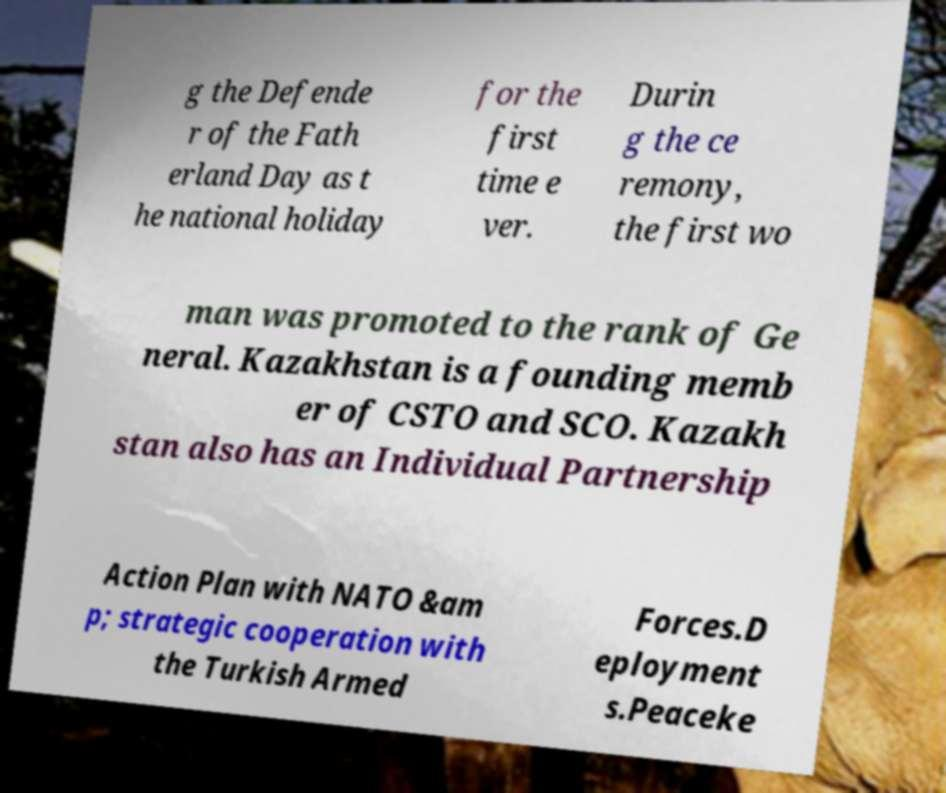Please read and relay the text visible in this image. What does it say? g the Defende r of the Fath erland Day as t he national holiday for the first time e ver. Durin g the ce remony, the first wo man was promoted to the rank of Ge neral. Kazakhstan is a founding memb er of CSTO and SCO. Kazakh stan also has an Individual Partnership Action Plan with NATO &am p; strategic cooperation with the Turkish Armed Forces.D eployment s.Peaceke 